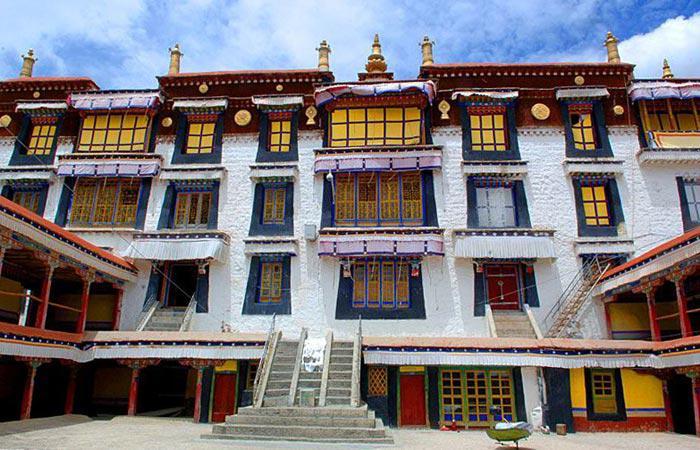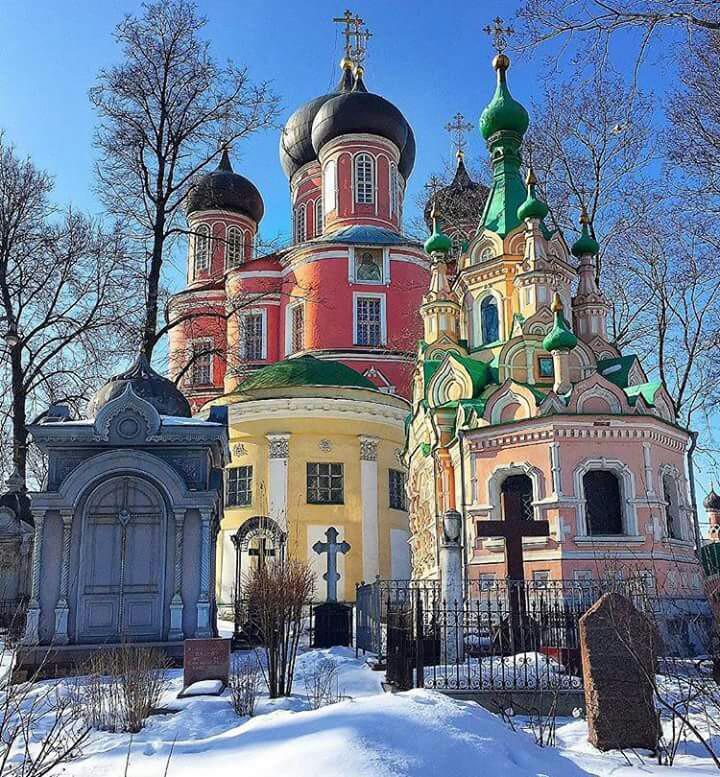The first image is the image on the left, the second image is the image on the right. Examine the images to the left and right. Is the description "To the right, we see a blue sky, with no clouds, behind the building." accurate? Answer yes or no. Yes. The first image is the image on the left, the second image is the image on the right. Assess this claim about the two images: "Both images contain one single building, made of mostly right angles.". Correct or not? Answer yes or no. No. 